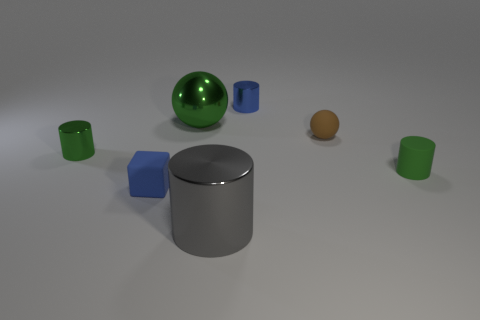What number of other things are the same size as the green metal cylinder?
Make the answer very short. 4. What number of blocks are either tiny red things or big things?
Your answer should be very brief. 0. There is a blue shiny object; does it have the same shape as the small green thing right of the gray shiny cylinder?
Provide a succinct answer. Yes. Is the number of green balls that are in front of the green matte object less than the number of tiny green metal cylinders?
Give a very brief answer. Yes. There is a gray metallic object; are there any small green cylinders left of it?
Offer a very short reply. Yes. Are there any tiny green metal things of the same shape as the large gray object?
Offer a terse response. Yes. The blue matte thing that is the same size as the brown rubber sphere is what shape?
Your response must be concise. Cube. How many objects are either large gray metal objects that are to the right of the tiny rubber block or green metallic cylinders?
Make the answer very short. 2. Is the rubber cylinder the same color as the shiny sphere?
Give a very brief answer. Yes. What is the size of the rubber thing on the left side of the tiny blue metallic thing?
Ensure brevity in your answer.  Small. 